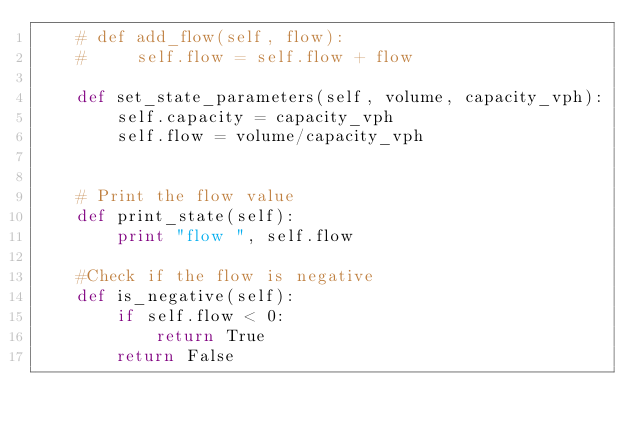Convert code to text. <code><loc_0><loc_0><loc_500><loc_500><_Python_>    # def add_flow(self, flow):
    #     self.flow = self.flow + flow

    def set_state_parameters(self, volume, capacity_vph):
        self.capacity = capacity_vph
        self.flow = volume/capacity_vph


    # Print the flow value
    def print_state(self):
        print "flow ", self.flow

    #Check if the flow is negative
    def is_negative(self):
        if self.flow < 0:
            return True
        return False
</code> 